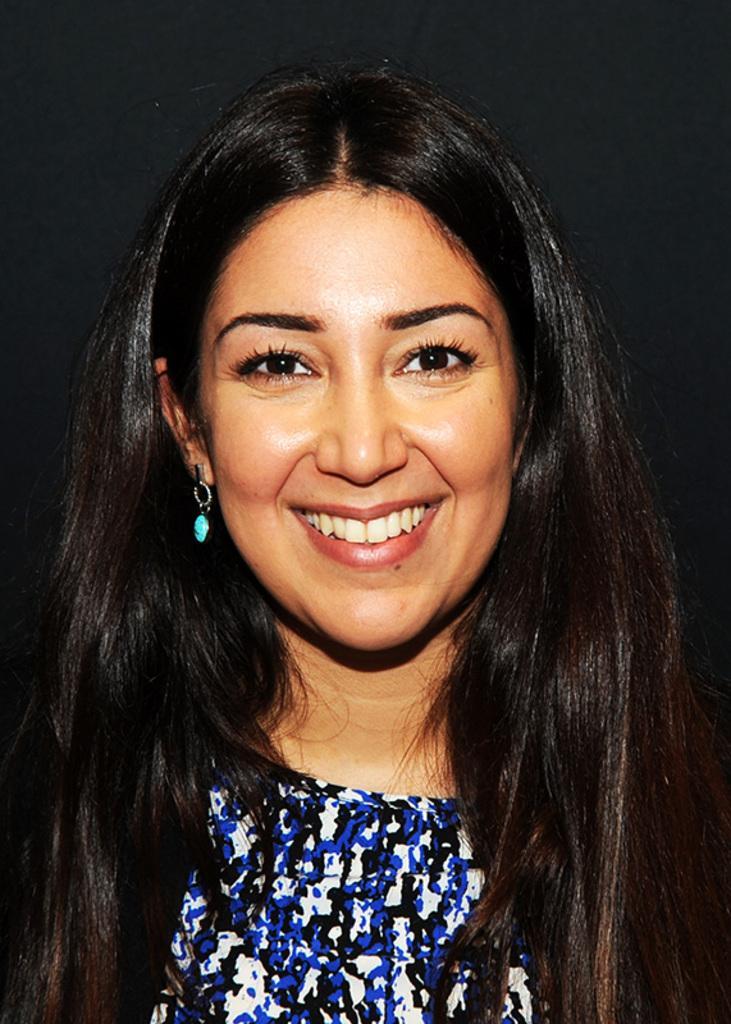In one or two sentences, can you explain what this image depicts? In this image we can see a woman smiling. 